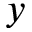Convert formula to latex. <formula><loc_0><loc_0><loc_500><loc_500>y</formula> 